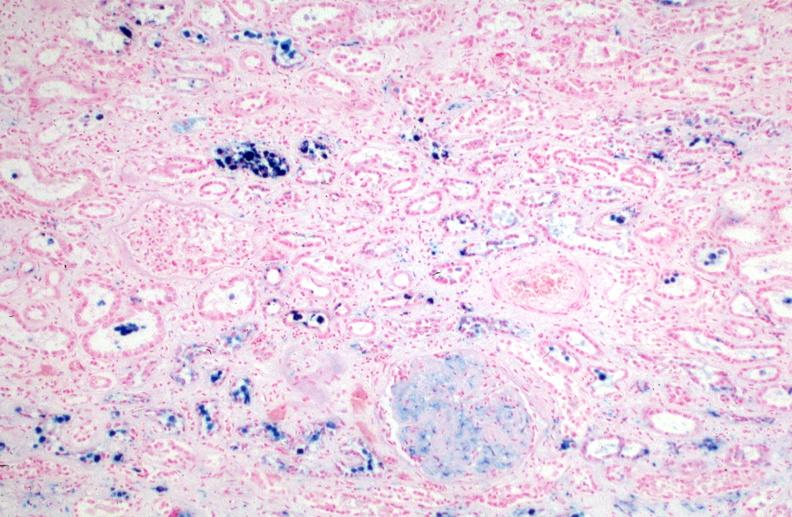s amyloid angiopathy r. endocrine caused by numerous blood transfusions.prusian blue?
Answer the question using a single word or phrase. No 